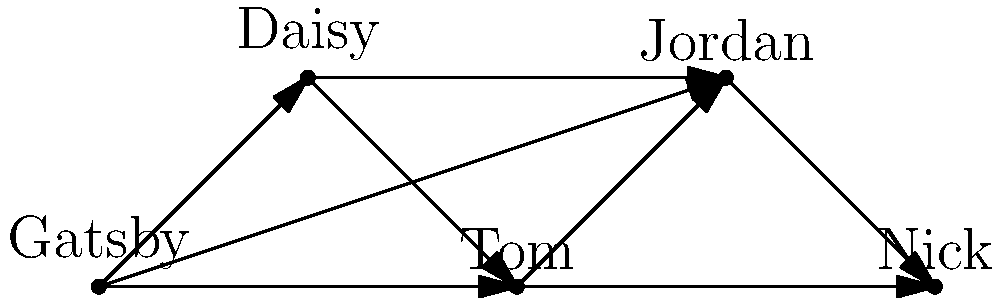In the network graph representing character relationships in F. Scott Fitzgerald's "The Great Gatsby," which character has the highest degree centrality (i.e., the most direct connections to other characters)? To determine the character with the highest degree centrality, we need to follow these steps:

1. Understand degree centrality: It's the number of direct connections a node (character) has in the network.

2. Count connections for each character:
   - Gatsby: 4 connections (to Daisy, Tom, Jordan, and Nick)
   - Daisy: 3 connections (to Gatsby, Tom, and Jordan)
   - Tom: 3 connections (to Gatsby, Daisy, and Jordan)
   - Jordan: 4 connections (to Gatsby, Daisy, Tom, and Nick)
   - Nick: 2 connections (to Gatsby and Jordan)

3. Compare the counts:
   Gatsby and Jordan both have 4 connections, which is the highest number.

4. Interpret the result:
   This high degree centrality for Gatsby and Jordan reflects their pivotal roles in the novel. Gatsby, as the titular character, is central to the plot and interacts with all other main characters. Jordan, as Daisy's friend and Nick's love interest, also serves as a key connector in the social network of the novel.

5. Consider the literary implications:
   This network structure emphasizes Fitzgerald's narrative technique, placing Gatsby at the center of the story while using Jordan as a conduit for information and social connections.
Answer: Gatsby and Jordan (tie) 